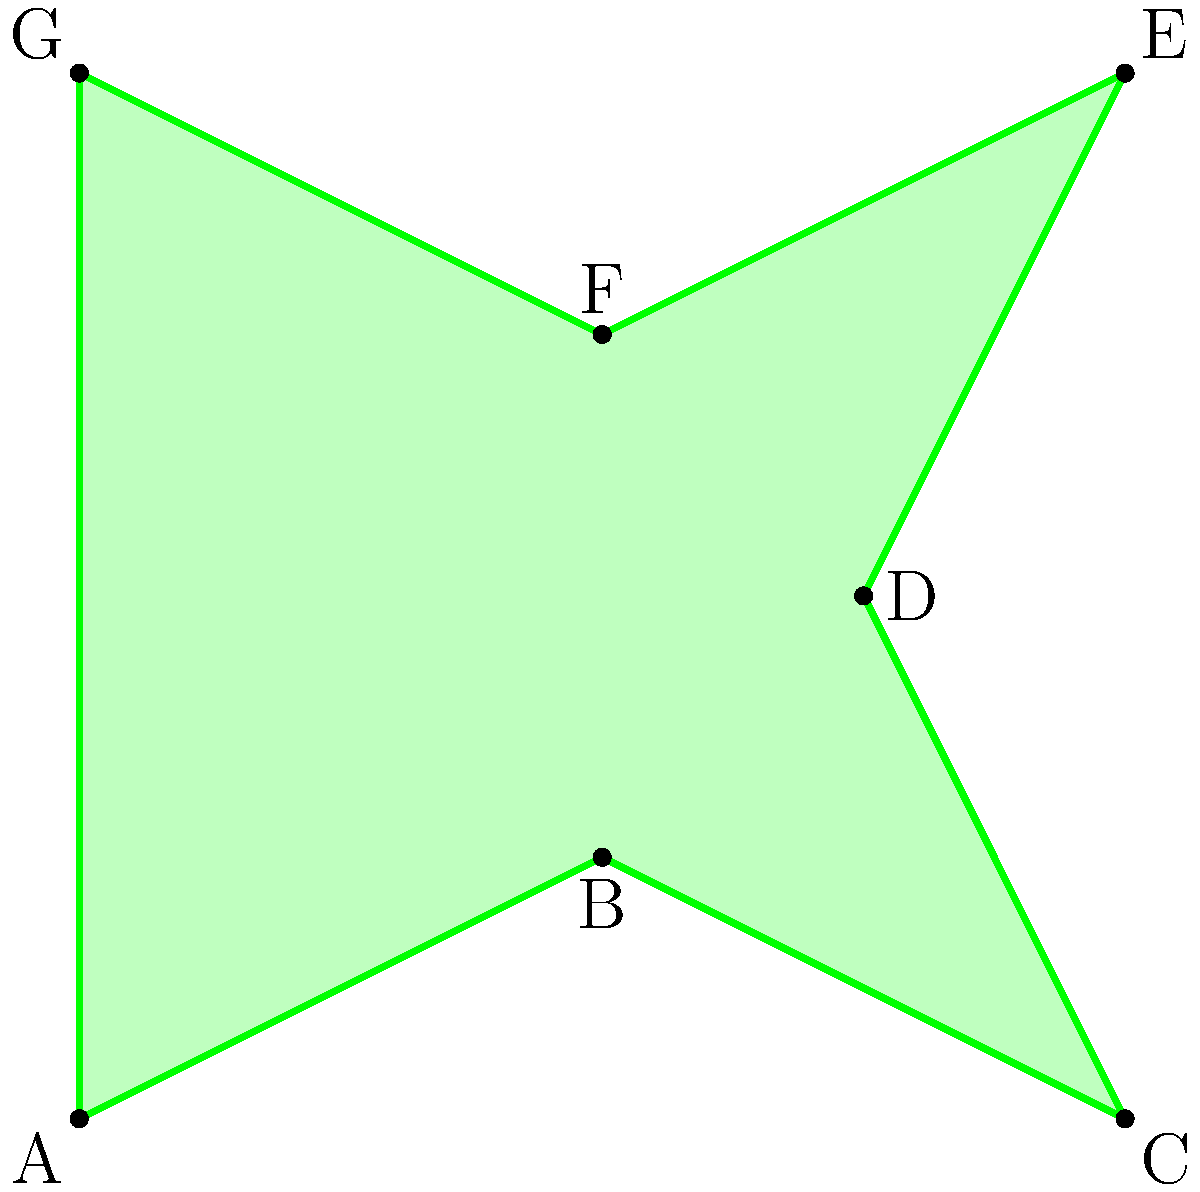In a world where reality bends to imagination, a mystical island emerges and vanishes with the tides. As a writer exploring magical realism, you've been tasked with calculating the area of this shifting landmass. The island's shape can be approximated by the irregular heptagon ABCDEFG shown in the figure, where each unit represents 1 km. Using the coordinate method, determine the area of the island in square kilometers. To calculate the area of the irregular heptagon, we can use the Shoelace formula (also known as the surveyor's formula). This method is particularly suitable for a writer exploring magical realism, as it weaves together geometry and poetry in a dance of numbers.

Step 1: Identify the coordinates of each vertex.
A(0,0), B(2,1), C(4,0), D(3,2), E(4,4), F(2,3), G(0,4)

Step 2: Apply the Shoelace formula:
Area = $\frac{1}{2}|((x_1y_2 + x_2y_3 + ... + x_ny_1) - (y_1x_2 + y_2x_3 + ... + y_nx_1))|$

Step 3: Calculate the products:
$(x_1y_2 + x_2y_3 + ... + x_ny_1)$:
$(0 \cdot 1) + (2 \cdot 0) + (4 \cdot 2) + (3 \cdot 4) + (4 \cdot 3) + (2 \cdot 4) + (0 \cdot 0) = 0 + 0 + 8 + 12 + 12 + 8 + 0 = 40$

$(y_1x_2 + y_2x_3 + ... + y_nx_1)$:
$(0 \cdot 2) + (1 \cdot 4) + (0 \cdot 3) + (2 \cdot 4) + (4 \cdot 2) + (3 \cdot 0) + (4 \cdot 0) = 0 + 4 + 0 + 8 + 8 + 0 + 0 = 20$

Step 4: Subtract and take the absolute value:
$|40 - 20| = 20$

Step 5: Multiply by $\frac{1}{2}$:
Area = $\frac{1}{2} \cdot 20 = 10$

Therefore, the area of the magical island is 10 square kilometers.
Answer: 10 km² 